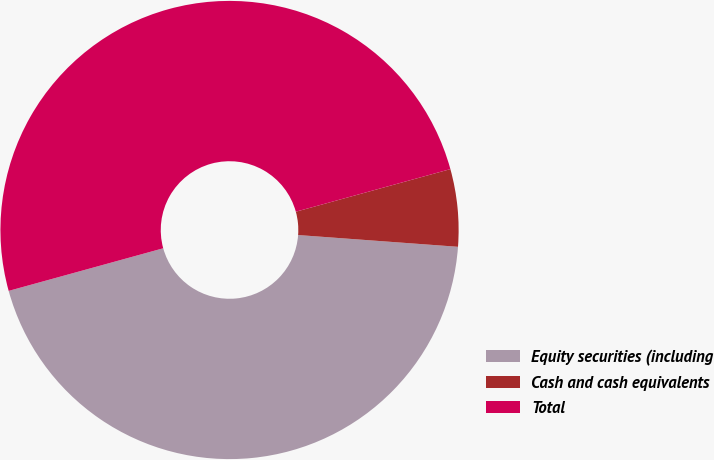Convert chart. <chart><loc_0><loc_0><loc_500><loc_500><pie_chart><fcel>Equity securities (including<fcel>Cash and cash equivalents<fcel>Total<nl><fcel>44.55%<fcel>5.45%<fcel>50.0%<nl></chart> 